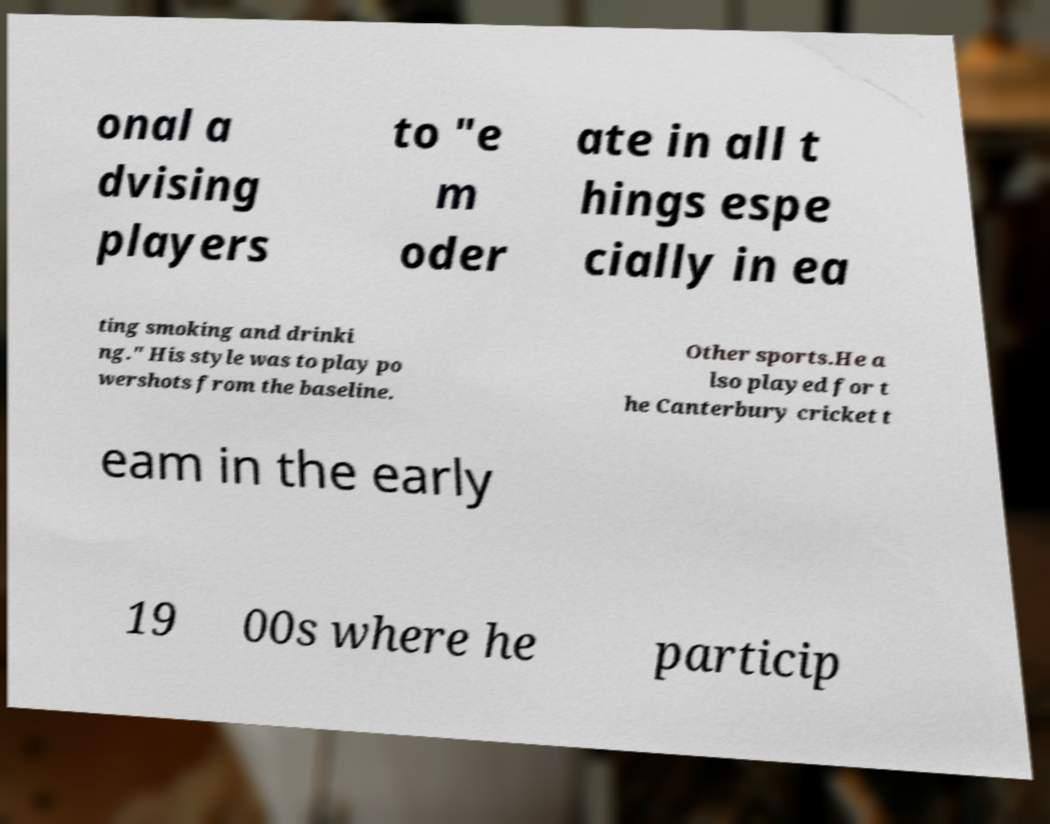I need the written content from this picture converted into text. Can you do that? onal a dvising players to "e m oder ate in all t hings espe cially in ea ting smoking and drinki ng." His style was to play po wershots from the baseline. Other sports.He a lso played for t he Canterbury cricket t eam in the early 19 00s where he particip 